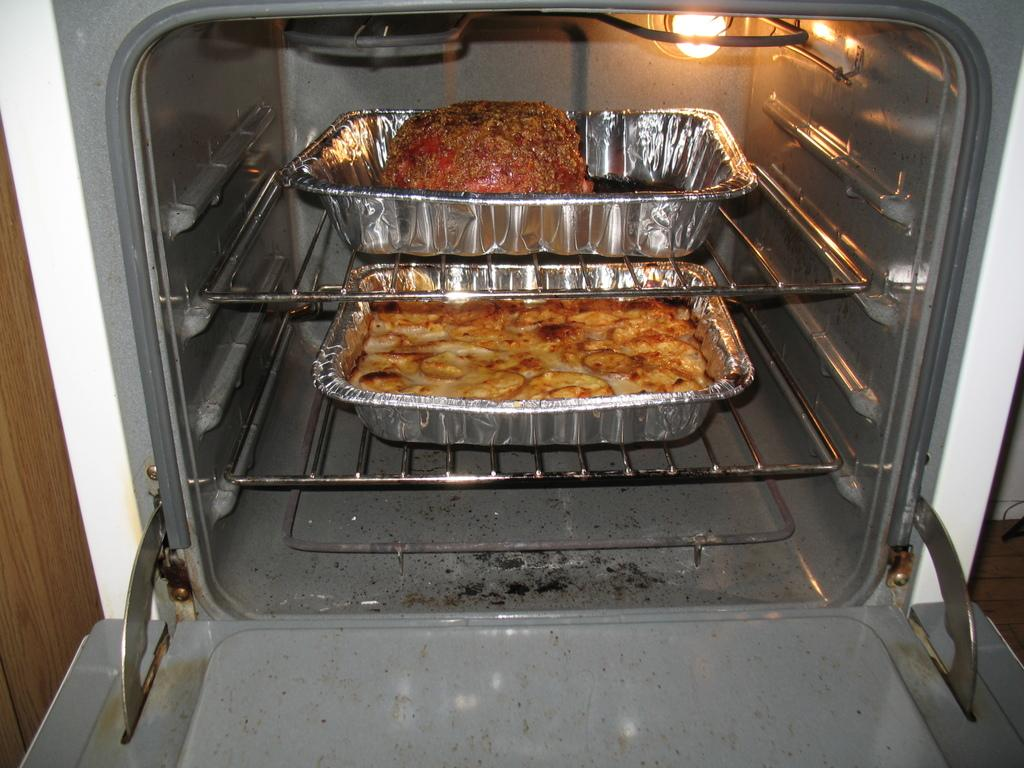What is present in the trays in the image? There is food in the trays. Where are the trays located in the image? The trays are placed on the racks of an oven. What type of boats can be seen sailing in the background of the image? There are no boats visible in the image; it features food in trays placed on the racks of an oven. What type of eggnog is being prepared in the trays? There is no eggnog present in the image; it features food in trays placed on the racks of an oven. 